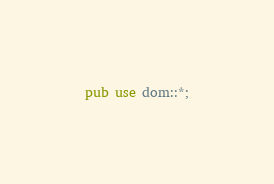<code> <loc_0><loc_0><loc_500><loc_500><_Rust_>
pub use dom::*;
</code> 